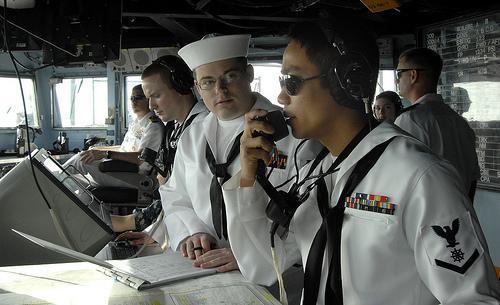How many people are in the picture?
Give a very brief answer. 6. 